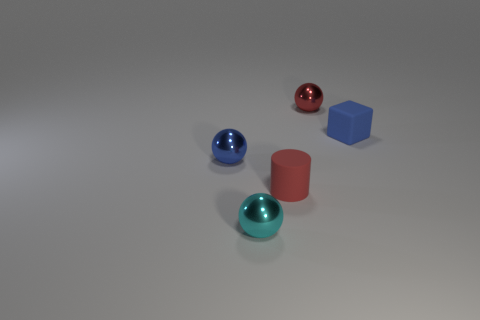Subtract all blue balls. How many balls are left? 2 Add 3 cyan shiny things. How many objects exist? 8 Subtract 1 blocks. How many blocks are left? 0 Subtract all blue balls. How many balls are left? 2 Subtract all blocks. How many objects are left? 4 Add 4 small blue balls. How many small blue balls are left? 5 Add 4 small red objects. How many small red objects exist? 6 Subtract 0 brown cubes. How many objects are left? 5 Subtract all purple cubes. Subtract all yellow spheres. How many cubes are left? 1 Subtract all big blue matte cylinders. Subtract all blue metal objects. How many objects are left? 4 